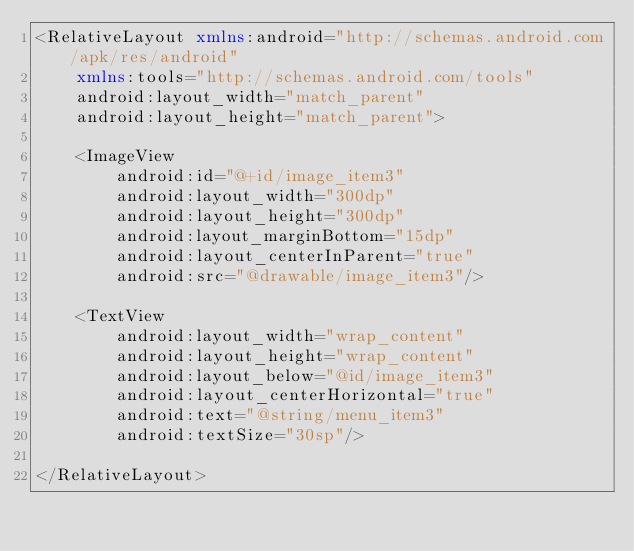Convert code to text. <code><loc_0><loc_0><loc_500><loc_500><_XML_><RelativeLayout xmlns:android="http://schemas.android.com/apk/res/android"
    xmlns:tools="http://schemas.android.com/tools"
    android:layout_width="match_parent"
    android:layout_height="match_parent">

    <ImageView
        android:id="@+id/image_item3"
        android:layout_width="300dp"
        android:layout_height="300dp"
        android:layout_marginBottom="15dp"
        android:layout_centerInParent="true"
        android:src="@drawable/image_item3"/>

    <TextView
        android:layout_width="wrap_content"
        android:layout_height="wrap_content"
        android:layout_below="@id/image_item3"
        android:layout_centerHorizontal="true"
        android:text="@string/menu_item3"
        android:textSize="30sp"/>

</RelativeLayout></code> 